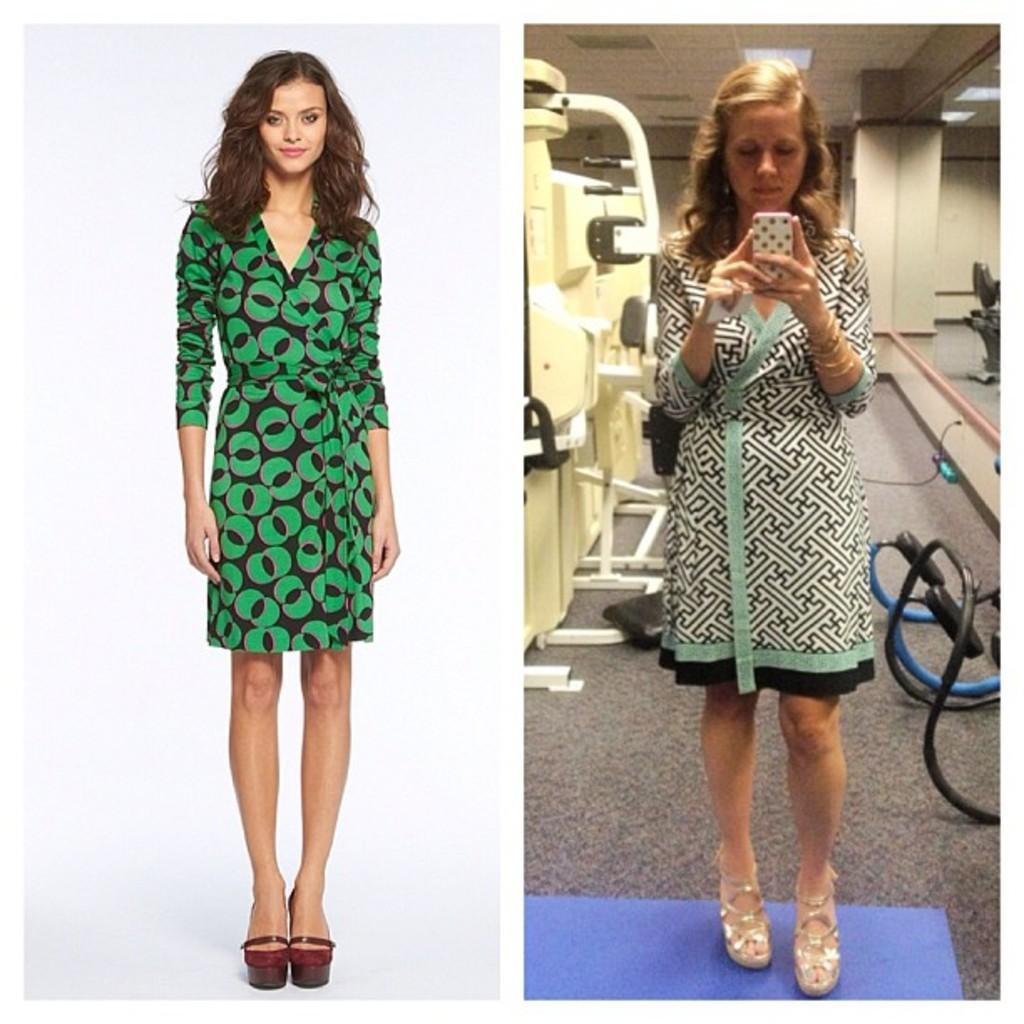In one or two sentences, can you explain what this image depicts? Here we can see collage of two pictures, on the left side picture we can see a woman is standing and smiling, on the right side picture we can see a woman is standing and holding a mobile phone, in the background there is gym equipment, we can see a mirror on the right side. 